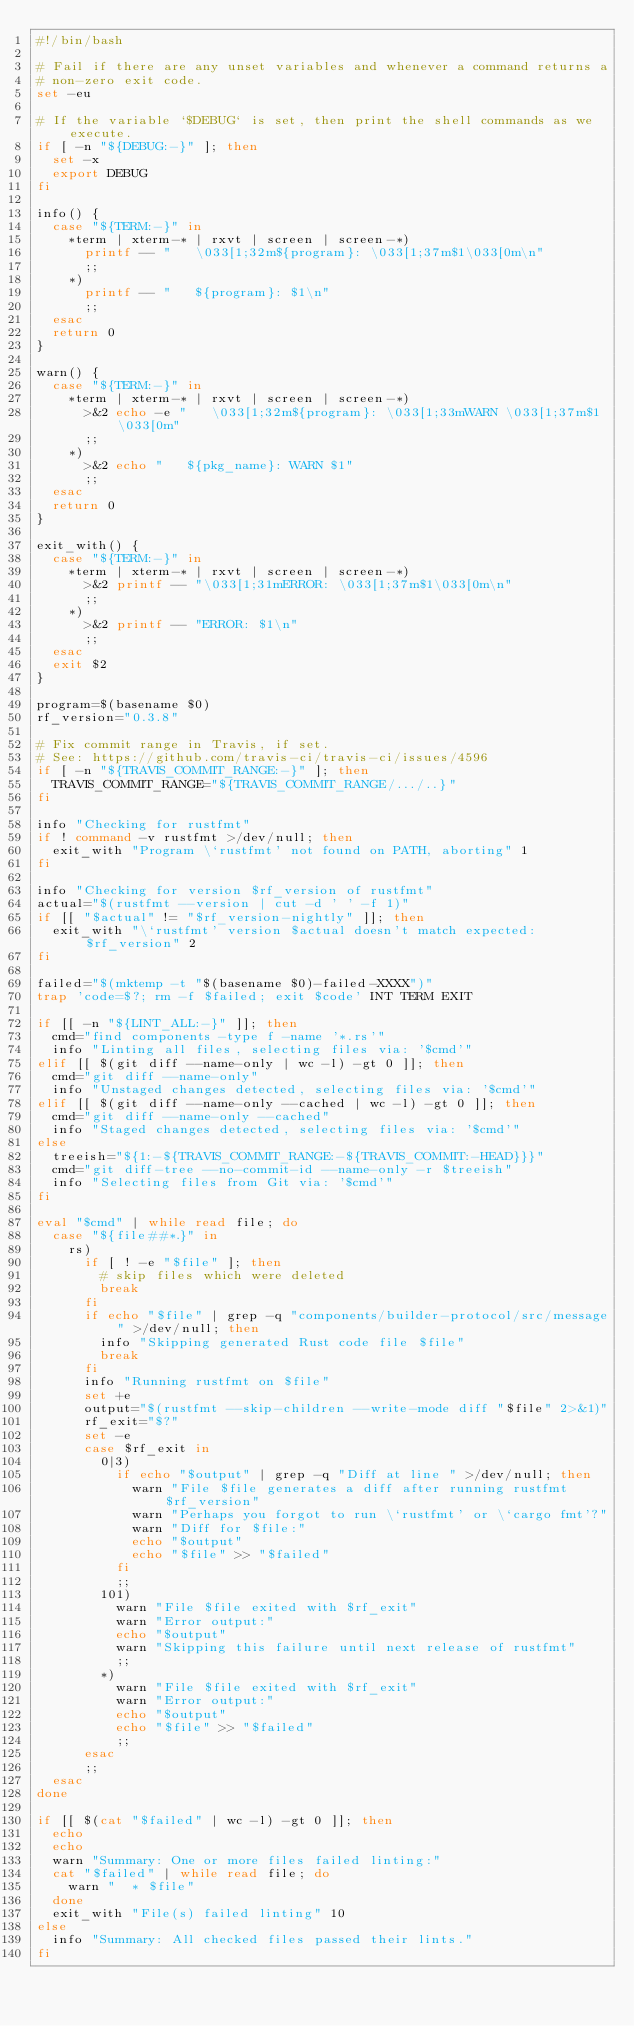<code> <loc_0><loc_0><loc_500><loc_500><_Bash_>#!/bin/bash

# Fail if there are any unset variables and whenever a command returns a
# non-zero exit code.
set -eu

# If the variable `$DEBUG` is set, then print the shell commands as we execute.
if [ -n "${DEBUG:-}" ]; then
  set -x
  export DEBUG
fi

info() {
  case "${TERM:-}" in
    *term | xterm-* | rxvt | screen | screen-*)
      printf -- "   \033[1;32m${program}: \033[1;37m$1\033[0m\n"
      ;;
    *)
      printf -- "   ${program}: $1\n"
      ;;
  esac
  return 0
}

warn() {
  case "${TERM:-}" in
    *term | xterm-* | rxvt | screen | screen-*)
      >&2 echo -e "   \033[1;32m${program}: \033[1;33mWARN \033[1;37m$1\033[0m"
      ;;
    *)
      >&2 echo "   ${pkg_name}: WARN $1"
      ;;
  esac
  return 0
}

exit_with() {
  case "${TERM:-}" in
    *term | xterm-* | rxvt | screen | screen-*)
      >&2 printf -- "\033[1;31mERROR: \033[1;37m$1\033[0m\n"
      ;;
    *)
      >&2 printf -- "ERROR: $1\n"
      ;;
  esac
  exit $2
}

program=$(basename $0)
rf_version="0.3.8"

# Fix commit range in Travis, if set.
# See: https://github.com/travis-ci/travis-ci/issues/4596
if [ -n "${TRAVIS_COMMIT_RANGE:-}" ]; then
  TRAVIS_COMMIT_RANGE="${TRAVIS_COMMIT_RANGE/.../..}"
fi

info "Checking for rustfmt"
if ! command -v rustfmt >/dev/null; then
  exit_with "Program \`rustfmt' not found on PATH, aborting" 1
fi

info "Checking for version $rf_version of rustfmt"
actual="$(rustfmt --version | cut -d ' ' -f 1)"
if [[ "$actual" != "$rf_version-nightly" ]]; then
  exit_with "\`rustfmt' version $actual doesn't match expected: $rf_version" 2
fi

failed="$(mktemp -t "$(basename $0)-failed-XXXX")"
trap 'code=$?; rm -f $failed; exit $code' INT TERM EXIT

if [[ -n "${LINT_ALL:-}" ]]; then
  cmd="find components -type f -name '*.rs'"
  info "Linting all files, selecting files via: '$cmd'"
elif [[ $(git diff --name-only | wc -l) -gt 0 ]]; then
  cmd="git diff --name-only"
  info "Unstaged changes detected, selecting files via: '$cmd'"
elif [[ $(git diff --name-only --cached | wc -l) -gt 0 ]]; then
  cmd="git diff --name-only --cached"
  info "Staged changes detected, selecting files via: '$cmd'"
else
  treeish="${1:-${TRAVIS_COMMIT_RANGE:-${TRAVIS_COMMIT:-HEAD}}}"
  cmd="git diff-tree --no-commit-id --name-only -r $treeish"
  info "Selecting files from Git via: '$cmd'"
fi

eval "$cmd" | while read file; do
  case "${file##*.}" in
    rs)
      if [ ! -e "$file" ]; then
        # skip files which were deleted
        break
      fi
      if echo "$file" | grep -q "components/builder-protocol/src/message" >/dev/null; then
        info "Skipping generated Rust code file $file"
        break
      fi
      info "Running rustfmt on $file"
      set +e
      output="$(rustfmt --skip-children --write-mode diff "$file" 2>&1)"
      rf_exit="$?"
      set -e
      case $rf_exit in
        0|3)
          if echo "$output" | grep -q "Diff at line " >/dev/null; then
            warn "File $file generates a diff after running rustfmt $rf_version"
            warn "Perhaps you forgot to run \`rustfmt' or \`cargo fmt'?"
            warn "Diff for $file:"
            echo "$output"
            echo "$file" >> "$failed"
          fi
          ;;
        101)
          warn "File $file exited with $rf_exit"
          warn "Error output:"
          echo "$output"
          warn "Skipping this failure until next release of rustfmt"
          ;;
        *)
          warn "File $file exited with $rf_exit"
          warn "Error output:"
          echo "$output"
          echo "$file" >> "$failed"
          ;;
      esac
      ;;
  esac
done

if [[ $(cat "$failed" | wc -l) -gt 0 ]]; then
  echo
  echo
  warn "Summary: One or more files failed linting:"
  cat "$failed" | while read file; do
    warn "  * $file"
  done
  exit_with "File(s) failed linting" 10
else
  info "Summary: All checked files passed their lints."
fi
</code> 